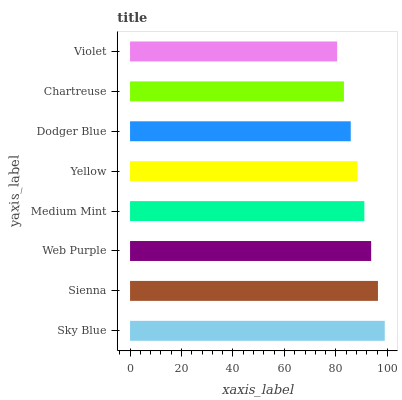Is Violet the minimum?
Answer yes or no. Yes. Is Sky Blue the maximum?
Answer yes or no. Yes. Is Sienna the minimum?
Answer yes or no. No. Is Sienna the maximum?
Answer yes or no. No. Is Sky Blue greater than Sienna?
Answer yes or no. Yes. Is Sienna less than Sky Blue?
Answer yes or no. Yes. Is Sienna greater than Sky Blue?
Answer yes or no. No. Is Sky Blue less than Sienna?
Answer yes or no. No. Is Medium Mint the high median?
Answer yes or no. Yes. Is Yellow the low median?
Answer yes or no. Yes. Is Yellow the high median?
Answer yes or no. No. Is Chartreuse the low median?
Answer yes or no. No. 